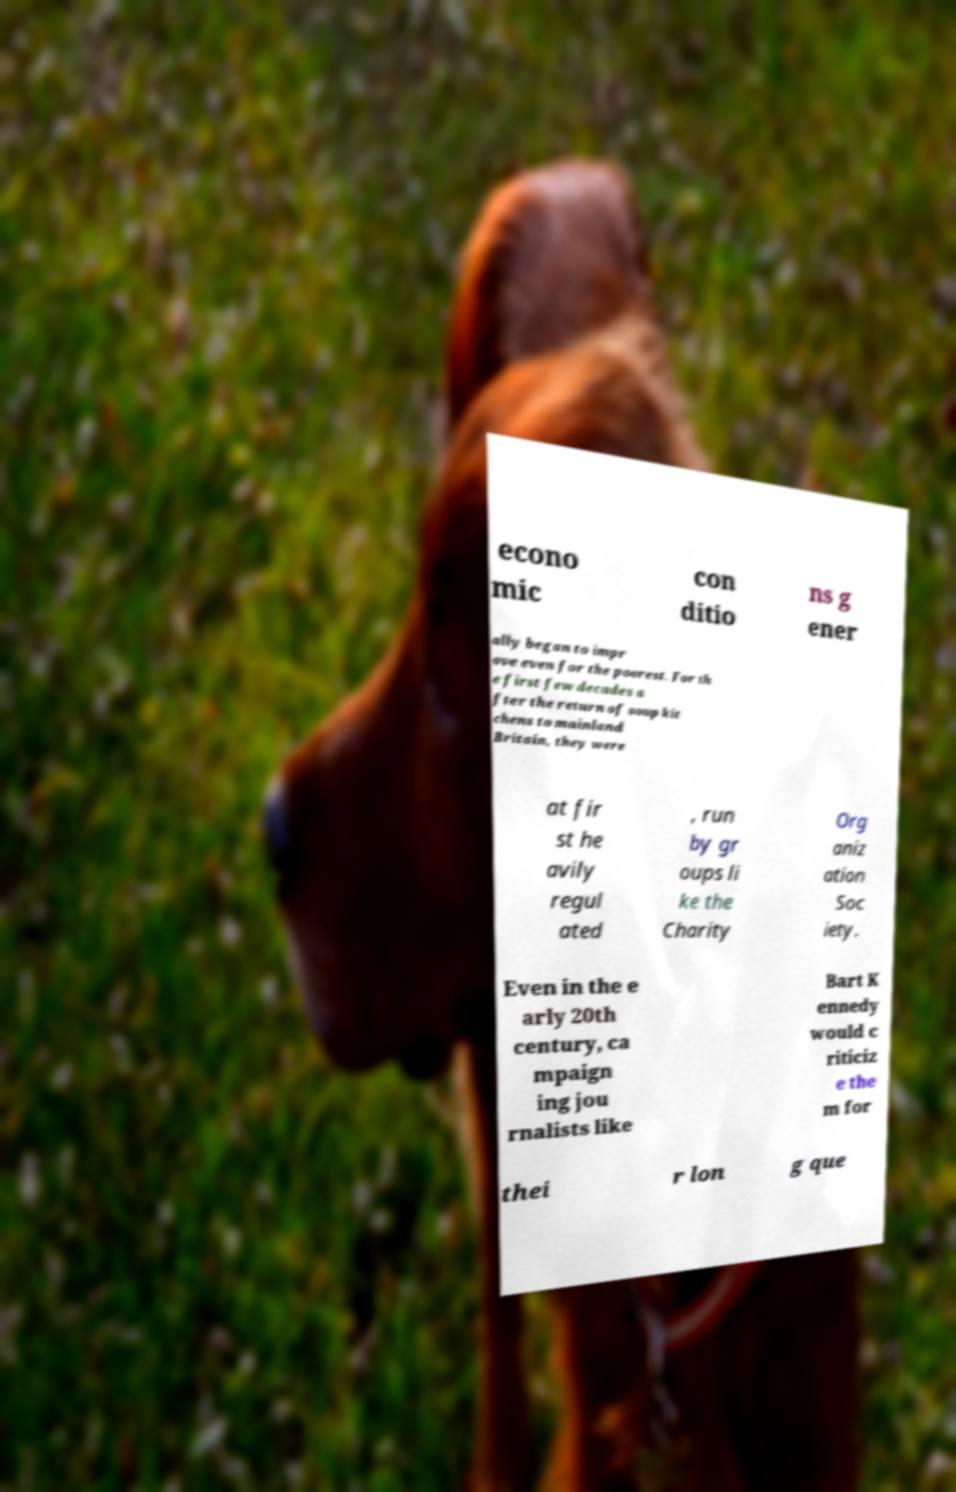Please read and relay the text visible in this image. What does it say? econo mic con ditio ns g ener ally began to impr ove even for the poorest. For th e first few decades a fter the return of soup kit chens to mainland Britain, they were at fir st he avily regul ated , run by gr oups li ke the Charity Org aniz ation Soc iety. Even in the e arly 20th century, ca mpaign ing jou rnalists like Bart K ennedy would c riticiz e the m for thei r lon g que 